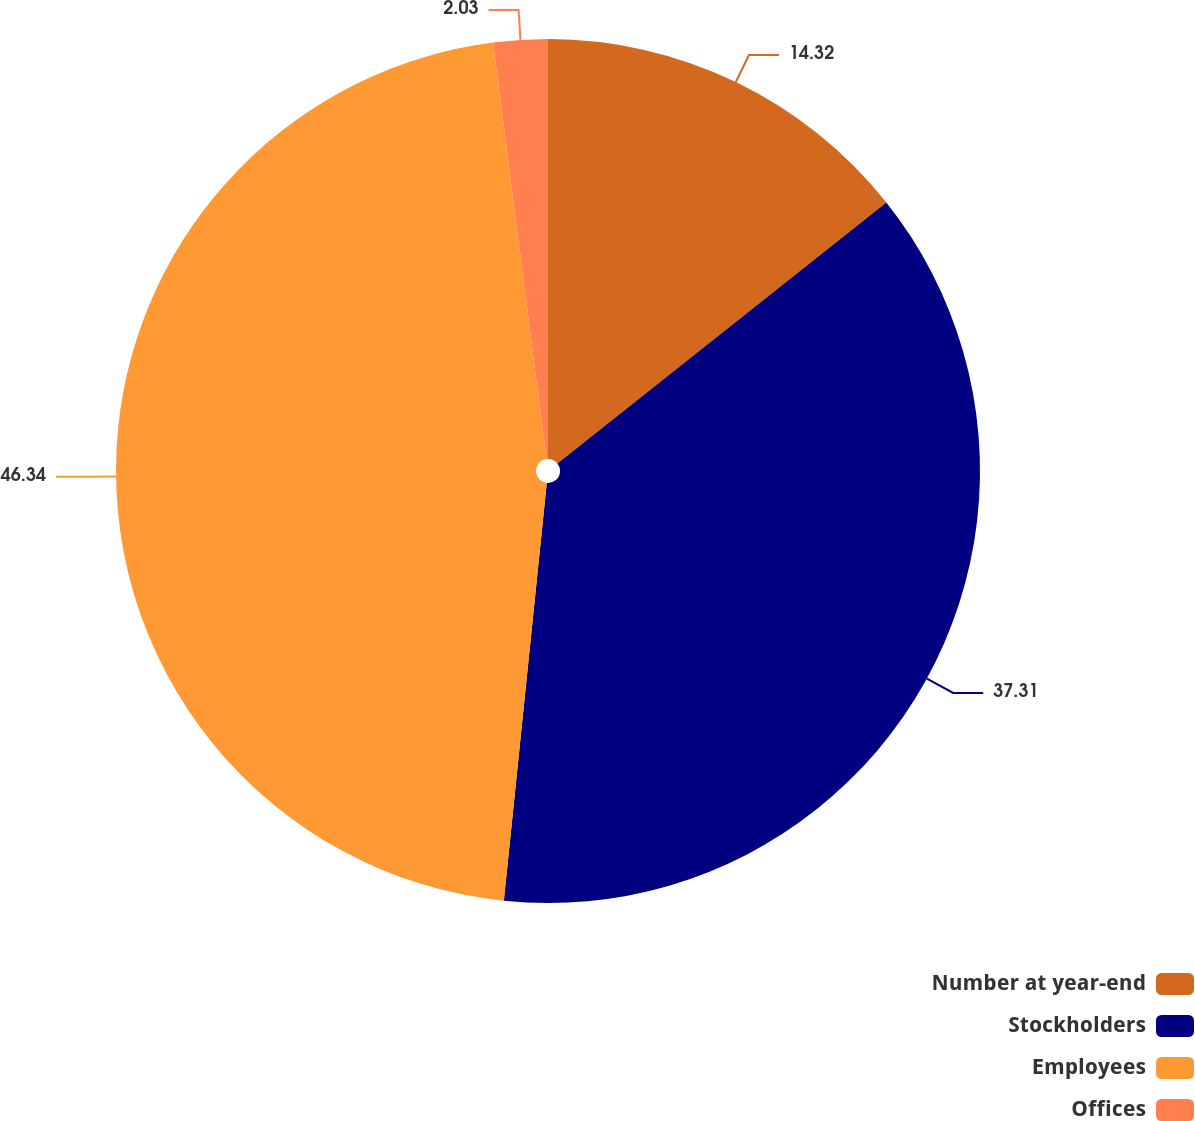Convert chart. <chart><loc_0><loc_0><loc_500><loc_500><pie_chart><fcel>Number at year-end<fcel>Stockholders<fcel>Employees<fcel>Offices<nl><fcel>14.32%<fcel>37.31%<fcel>46.34%<fcel>2.03%<nl></chart> 